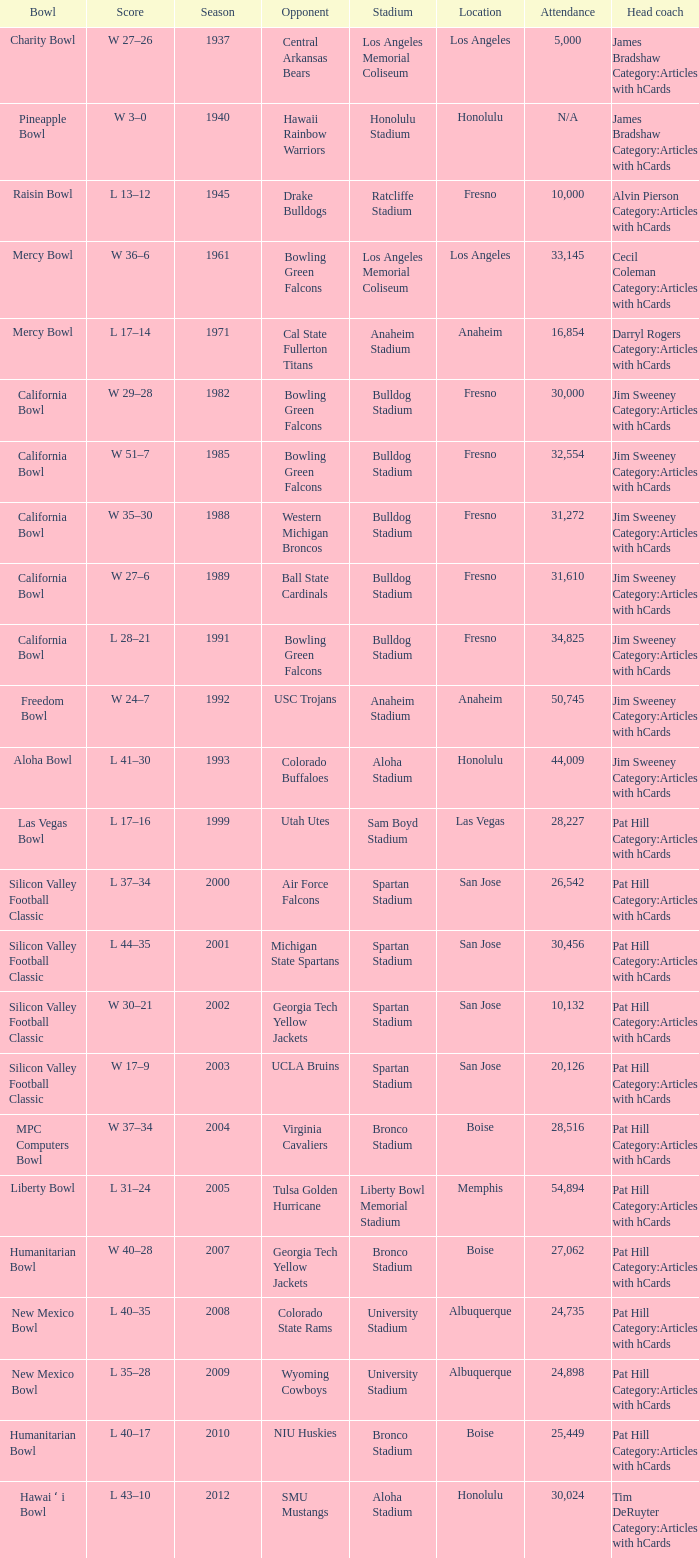In which venue did the california bowl take place, attended by 30,000 people? Fresno. 